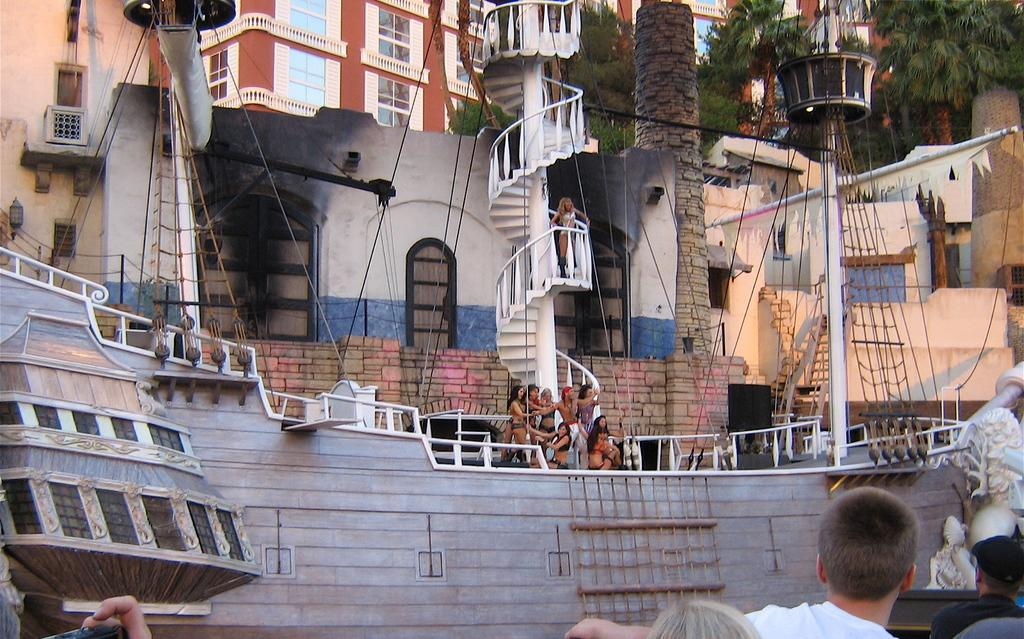What is the main subject of the image? The main subject of the image is a large boat. Where is the boat located in relation to other structures or objects? The boat is in front of a house. Are there any people present in the image? Yes, there are people on the boat. What type of sugar is being sold in the shop near the boat? There is no shop or sugar present in the image; it only features a large boat in front of a house with people on it. 